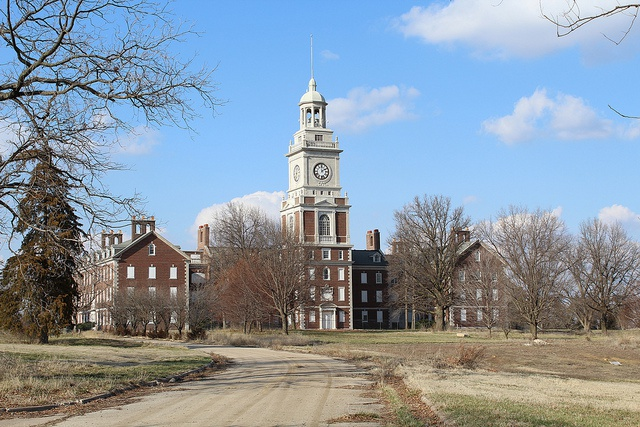Describe the objects in this image and their specific colors. I can see clock in lightblue, lightgray, darkgray, gray, and black tones and clock in lightblue, lightgray, and darkgray tones in this image. 